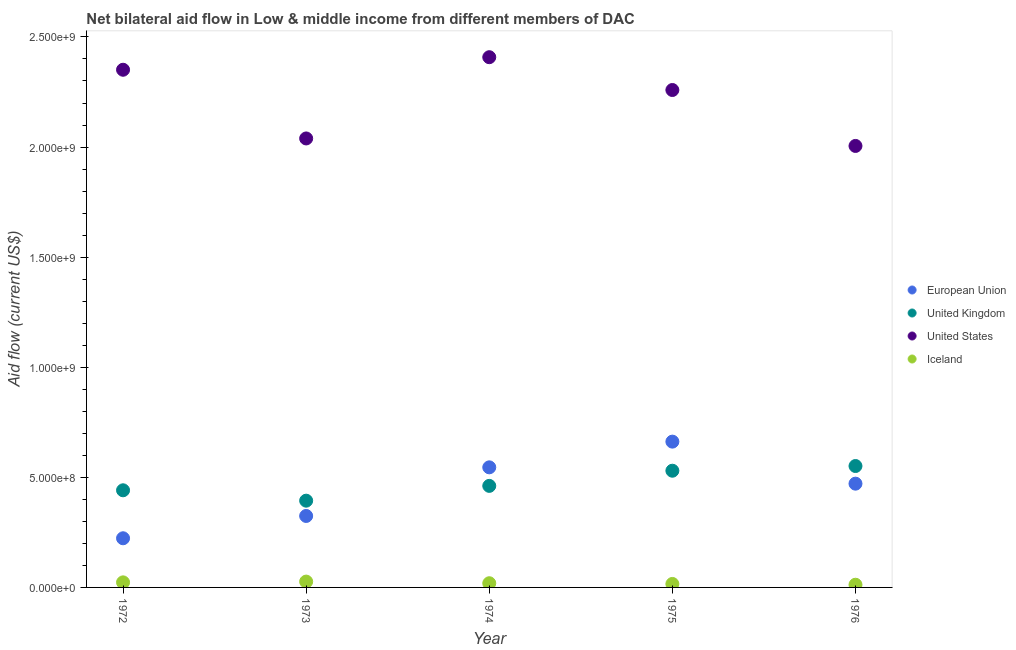What is the amount of aid given by eu in 1974?
Offer a terse response. 5.45e+08. Across all years, what is the maximum amount of aid given by uk?
Ensure brevity in your answer.  5.51e+08. Across all years, what is the minimum amount of aid given by iceland?
Your answer should be very brief. 1.22e+07. In which year was the amount of aid given by us maximum?
Your answer should be very brief. 1974. In which year was the amount of aid given by eu minimum?
Your answer should be very brief. 1972. What is the total amount of aid given by iceland in the graph?
Give a very brief answer. 9.66e+07. What is the difference between the amount of aid given by us in 1973 and that in 1975?
Provide a succinct answer. -2.20e+08. What is the difference between the amount of aid given by us in 1975 and the amount of aid given by uk in 1973?
Offer a terse response. 1.87e+09. What is the average amount of aid given by eu per year?
Keep it short and to the point. 4.45e+08. In the year 1974, what is the difference between the amount of aid given by us and amount of aid given by uk?
Keep it short and to the point. 1.95e+09. In how many years, is the amount of aid given by iceland greater than 1500000000 US$?
Your answer should be very brief. 0. What is the ratio of the amount of aid given by uk in 1972 to that in 1976?
Provide a succinct answer. 0.8. Is the amount of aid given by iceland in 1974 less than that in 1976?
Your response must be concise. No. What is the difference between the highest and the second highest amount of aid given by eu?
Ensure brevity in your answer.  1.17e+08. What is the difference between the highest and the lowest amount of aid given by iceland?
Your answer should be compact. 1.43e+07. In how many years, is the amount of aid given by eu greater than the average amount of aid given by eu taken over all years?
Your answer should be compact. 3. Is it the case that in every year, the sum of the amount of aid given by us and amount of aid given by eu is greater than the sum of amount of aid given by uk and amount of aid given by iceland?
Your answer should be very brief. No. Does the amount of aid given by iceland monotonically increase over the years?
Your answer should be very brief. No. Is the amount of aid given by uk strictly greater than the amount of aid given by eu over the years?
Your response must be concise. No. How many years are there in the graph?
Provide a short and direct response. 5. What is the difference between two consecutive major ticks on the Y-axis?
Provide a succinct answer. 5.00e+08. Where does the legend appear in the graph?
Give a very brief answer. Center right. How are the legend labels stacked?
Offer a terse response. Vertical. What is the title of the graph?
Ensure brevity in your answer.  Net bilateral aid flow in Low & middle income from different members of DAC. What is the label or title of the Y-axis?
Make the answer very short. Aid flow (current US$). What is the Aid flow (current US$) of European Union in 1972?
Keep it short and to the point. 2.23e+08. What is the Aid flow (current US$) of United Kingdom in 1972?
Offer a very short reply. 4.41e+08. What is the Aid flow (current US$) in United States in 1972?
Offer a terse response. 2.35e+09. What is the Aid flow (current US$) of Iceland in 1972?
Your response must be concise. 2.30e+07. What is the Aid flow (current US$) of European Union in 1973?
Your answer should be very brief. 3.25e+08. What is the Aid flow (current US$) of United Kingdom in 1973?
Your answer should be compact. 3.94e+08. What is the Aid flow (current US$) in United States in 1973?
Provide a short and direct response. 2.04e+09. What is the Aid flow (current US$) of Iceland in 1973?
Give a very brief answer. 2.65e+07. What is the Aid flow (current US$) in European Union in 1974?
Offer a terse response. 5.45e+08. What is the Aid flow (current US$) of United Kingdom in 1974?
Your answer should be very brief. 4.61e+08. What is the Aid flow (current US$) in United States in 1974?
Provide a short and direct response. 2.41e+09. What is the Aid flow (current US$) in Iceland in 1974?
Your answer should be very brief. 1.90e+07. What is the Aid flow (current US$) of European Union in 1975?
Keep it short and to the point. 6.62e+08. What is the Aid flow (current US$) of United Kingdom in 1975?
Provide a succinct answer. 5.30e+08. What is the Aid flow (current US$) in United States in 1975?
Make the answer very short. 2.26e+09. What is the Aid flow (current US$) in Iceland in 1975?
Provide a short and direct response. 1.58e+07. What is the Aid flow (current US$) in European Union in 1976?
Make the answer very short. 4.71e+08. What is the Aid flow (current US$) of United Kingdom in 1976?
Your answer should be very brief. 5.51e+08. What is the Aid flow (current US$) in United States in 1976?
Keep it short and to the point. 2.00e+09. What is the Aid flow (current US$) in Iceland in 1976?
Make the answer very short. 1.22e+07. Across all years, what is the maximum Aid flow (current US$) in European Union?
Your response must be concise. 6.62e+08. Across all years, what is the maximum Aid flow (current US$) of United Kingdom?
Ensure brevity in your answer.  5.51e+08. Across all years, what is the maximum Aid flow (current US$) in United States?
Your answer should be very brief. 2.41e+09. Across all years, what is the maximum Aid flow (current US$) in Iceland?
Give a very brief answer. 2.65e+07. Across all years, what is the minimum Aid flow (current US$) in European Union?
Keep it short and to the point. 2.23e+08. Across all years, what is the minimum Aid flow (current US$) in United Kingdom?
Offer a terse response. 3.94e+08. Across all years, what is the minimum Aid flow (current US$) in United States?
Provide a succinct answer. 2.00e+09. Across all years, what is the minimum Aid flow (current US$) in Iceland?
Your response must be concise. 1.22e+07. What is the total Aid flow (current US$) of European Union in the graph?
Offer a very short reply. 2.23e+09. What is the total Aid flow (current US$) of United Kingdom in the graph?
Keep it short and to the point. 2.38e+09. What is the total Aid flow (current US$) of United States in the graph?
Offer a very short reply. 1.11e+1. What is the total Aid flow (current US$) of Iceland in the graph?
Your response must be concise. 9.66e+07. What is the difference between the Aid flow (current US$) of European Union in 1972 and that in 1973?
Offer a terse response. -1.01e+08. What is the difference between the Aid flow (current US$) in United Kingdom in 1972 and that in 1973?
Your answer should be very brief. 4.72e+07. What is the difference between the Aid flow (current US$) in United States in 1972 and that in 1973?
Your answer should be very brief. 3.12e+08. What is the difference between the Aid flow (current US$) of Iceland in 1972 and that in 1973?
Provide a short and direct response. -3.48e+06. What is the difference between the Aid flow (current US$) of European Union in 1972 and that in 1974?
Offer a terse response. -3.22e+08. What is the difference between the Aid flow (current US$) of United Kingdom in 1972 and that in 1974?
Provide a succinct answer. -2.00e+07. What is the difference between the Aid flow (current US$) in United States in 1972 and that in 1974?
Offer a very short reply. -5.70e+07. What is the difference between the Aid flow (current US$) in Iceland in 1972 and that in 1974?
Provide a short and direct response. 3.97e+06. What is the difference between the Aid flow (current US$) in European Union in 1972 and that in 1975?
Provide a succinct answer. -4.39e+08. What is the difference between the Aid flow (current US$) of United Kingdom in 1972 and that in 1975?
Your answer should be very brief. -8.89e+07. What is the difference between the Aid flow (current US$) in United States in 1972 and that in 1975?
Your answer should be very brief. 9.20e+07. What is the difference between the Aid flow (current US$) of Iceland in 1972 and that in 1975?
Offer a very short reply. 7.21e+06. What is the difference between the Aid flow (current US$) in European Union in 1972 and that in 1976?
Provide a succinct answer. -2.48e+08. What is the difference between the Aid flow (current US$) in United Kingdom in 1972 and that in 1976?
Provide a succinct answer. -1.10e+08. What is the difference between the Aid flow (current US$) of United States in 1972 and that in 1976?
Give a very brief answer. 3.46e+08. What is the difference between the Aid flow (current US$) in Iceland in 1972 and that in 1976?
Provide a succinct answer. 1.08e+07. What is the difference between the Aid flow (current US$) of European Union in 1973 and that in 1974?
Give a very brief answer. -2.21e+08. What is the difference between the Aid flow (current US$) in United Kingdom in 1973 and that in 1974?
Give a very brief answer. -6.72e+07. What is the difference between the Aid flow (current US$) of United States in 1973 and that in 1974?
Provide a short and direct response. -3.69e+08. What is the difference between the Aid flow (current US$) of Iceland in 1973 and that in 1974?
Your answer should be compact. 7.45e+06. What is the difference between the Aid flow (current US$) of European Union in 1973 and that in 1975?
Keep it short and to the point. -3.38e+08. What is the difference between the Aid flow (current US$) in United Kingdom in 1973 and that in 1975?
Provide a succinct answer. -1.36e+08. What is the difference between the Aid flow (current US$) in United States in 1973 and that in 1975?
Provide a succinct answer. -2.20e+08. What is the difference between the Aid flow (current US$) of Iceland in 1973 and that in 1975?
Your response must be concise. 1.07e+07. What is the difference between the Aid flow (current US$) of European Union in 1973 and that in 1976?
Your answer should be very brief. -1.47e+08. What is the difference between the Aid flow (current US$) of United Kingdom in 1973 and that in 1976?
Ensure brevity in your answer.  -1.57e+08. What is the difference between the Aid flow (current US$) of United States in 1973 and that in 1976?
Your answer should be very brief. 3.40e+07. What is the difference between the Aid flow (current US$) of Iceland in 1973 and that in 1976?
Provide a short and direct response. 1.43e+07. What is the difference between the Aid flow (current US$) of European Union in 1974 and that in 1975?
Keep it short and to the point. -1.17e+08. What is the difference between the Aid flow (current US$) of United Kingdom in 1974 and that in 1975?
Offer a very short reply. -6.89e+07. What is the difference between the Aid flow (current US$) in United States in 1974 and that in 1975?
Keep it short and to the point. 1.49e+08. What is the difference between the Aid flow (current US$) in Iceland in 1974 and that in 1975?
Give a very brief answer. 3.24e+06. What is the difference between the Aid flow (current US$) of European Union in 1974 and that in 1976?
Offer a very short reply. 7.42e+07. What is the difference between the Aid flow (current US$) of United Kingdom in 1974 and that in 1976?
Make the answer very short. -9.02e+07. What is the difference between the Aid flow (current US$) of United States in 1974 and that in 1976?
Give a very brief answer. 4.03e+08. What is the difference between the Aid flow (current US$) in Iceland in 1974 and that in 1976?
Offer a terse response. 6.82e+06. What is the difference between the Aid flow (current US$) in European Union in 1975 and that in 1976?
Offer a very short reply. 1.91e+08. What is the difference between the Aid flow (current US$) in United Kingdom in 1975 and that in 1976?
Ensure brevity in your answer.  -2.13e+07. What is the difference between the Aid flow (current US$) of United States in 1975 and that in 1976?
Provide a succinct answer. 2.54e+08. What is the difference between the Aid flow (current US$) of Iceland in 1975 and that in 1976?
Offer a terse response. 3.58e+06. What is the difference between the Aid flow (current US$) in European Union in 1972 and the Aid flow (current US$) in United Kingdom in 1973?
Make the answer very short. -1.71e+08. What is the difference between the Aid flow (current US$) in European Union in 1972 and the Aid flow (current US$) in United States in 1973?
Your answer should be compact. -1.82e+09. What is the difference between the Aid flow (current US$) of European Union in 1972 and the Aid flow (current US$) of Iceland in 1973?
Your answer should be compact. 1.97e+08. What is the difference between the Aid flow (current US$) of United Kingdom in 1972 and the Aid flow (current US$) of United States in 1973?
Provide a short and direct response. -1.60e+09. What is the difference between the Aid flow (current US$) in United Kingdom in 1972 and the Aid flow (current US$) in Iceland in 1973?
Provide a short and direct response. 4.15e+08. What is the difference between the Aid flow (current US$) in United States in 1972 and the Aid flow (current US$) in Iceland in 1973?
Make the answer very short. 2.32e+09. What is the difference between the Aid flow (current US$) in European Union in 1972 and the Aid flow (current US$) in United Kingdom in 1974?
Your answer should be very brief. -2.38e+08. What is the difference between the Aid flow (current US$) in European Union in 1972 and the Aid flow (current US$) in United States in 1974?
Your answer should be very brief. -2.18e+09. What is the difference between the Aid flow (current US$) of European Union in 1972 and the Aid flow (current US$) of Iceland in 1974?
Your answer should be compact. 2.04e+08. What is the difference between the Aid flow (current US$) in United Kingdom in 1972 and the Aid flow (current US$) in United States in 1974?
Provide a succinct answer. -1.97e+09. What is the difference between the Aid flow (current US$) in United Kingdom in 1972 and the Aid flow (current US$) in Iceland in 1974?
Your response must be concise. 4.22e+08. What is the difference between the Aid flow (current US$) of United States in 1972 and the Aid flow (current US$) of Iceland in 1974?
Give a very brief answer. 2.33e+09. What is the difference between the Aid flow (current US$) of European Union in 1972 and the Aid flow (current US$) of United Kingdom in 1975?
Ensure brevity in your answer.  -3.07e+08. What is the difference between the Aid flow (current US$) in European Union in 1972 and the Aid flow (current US$) in United States in 1975?
Your answer should be very brief. -2.04e+09. What is the difference between the Aid flow (current US$) of European Union in 1972 and the Aid flow (current US$) of Iceland in 1975?
Provide a short and direct response. 2.07e+08. What is the difference between the Aid flow (current US$) of United Kingdom in 1972 and the Aid flow (current US$) of United States in 1975?
Offer a terse response. -1.82e+09. What is the difference between the Aid flow (current US$) of United Kingdom in 1972 and the Aid flow (current US$) of Iceland in 1975?
Your answer should be compact. 4.25e+08. What is the difference between the Aid flow (current US$) in United States in 1972 and the Aid flow (current US$) in Iceland in 1975?
Ensure brevity in your answer.  2.34e+09. What is the difference between the Aid flow (current US$) of European Union in 1972 and the Aid flow (current US$) of United Kingdom in 1976?
Keep it short and to the point. -3.28e+08. What is the difference between the Aid flow (current US$) in European Union in 1972 and the Aid flow (current US$) in United States in 1976?
Your answer should be compact. -1.78e+09. What is the difference between the Aid flow (current US$) in European Union in 1972 and the Aid flow (current US$) in Iceland in 1976?
Keep it short and to the point. 2.11e+08. What is the difference between the Aid flow (current US$) in United Kingdom in 1972 and the Aid flow (current US$) in United States in 1976?
Give a very brief answer. -1.56e+09. What is the difference between the Aid flow (current US$) of United Kingdom in 1972 and the Aid flow (current US$) of Iceland in 1976?
Make the answer very short. 4.29e+08. What is the difference between the Aid flow (current US$) of United States in 1972 and the Aid flow (current US$) of Iceland in 1976?
Ensure brevity in your answer.  2.34e+09. What is the difference between the Aid flow (current US$) in European Union in 1973 and the Aid flow (current US$) in United Kingdom in 1974?
Provide a short and direct response. -1.37e+08. What is the difference between the Aid flow (current US$) in European Union in 1973 and the Aid flow (current US$) in United States in 1974?
Keep it short and to the point. -2.08e+09. What is the difference between the Aid flow (current US$) of European Union in 1973 and the Aid flow (current US$) of Iceland in 1974?
Keep it short and to the point. 3.06e+08. What is the difference between the Aid flow (current US$) in United Kingdom in 1973 and the Aid flow (current US$) in United States in 1974?
Offer a very short reply. -2.01e+09. What is the difference between the Aid flow (current US$) of United Kingdom in 1973 and the Aid flow (current US$) of Iceland in 1974?
Your answer should be compact. 3.75e+08. What is the difference between the Aid flow (current US$) in United States in 1973 and the Aid flow (current US$) in Iceland in 1974?
Keep it short and to the point. 2.02e+09. What is the difference between the Aid flow (current US$) in European Union in 1973 and the Aid flow (current US$) in United Kingdom in 1975?
Give a very brief answer. -2.05e+08. What is the difference between the Aid flow (current US$) in European Union in 1973 and the Aid flow (current US$) in United States in 1975?
Keep it short and to the point. -1.93e+09. What is the difference between the Aid flow (current US$) of European Union in 1973 and the Aid flow (current US$) of Iceland in 1975?
Your answer should be compact. 3.09e+08. What is the difference between the Aid flow (current US$) in United Kingdom in 1973 and the Aid flow (current US$) in United States in 1975?
Your answer should be compact. -1.87e+09. What is the difference between the Aid flow (current US$) of United Kingdom in 1973 and the Aid flow (current US$) of Iceland in 1975?
Keep it short and to the point. 3.78e+08. What is the difference between the Aid flow (current US$) in United States in 1973 and the Aid flow (current US$) in Iceland in 1975?
Your answer should be compact. 2.02e+09. What is the difference between the Aid flow (current US$) of European Union in 1973 and the Aid flow (current US$) of United Kingdom in 1976?
Your answer should be compact. -2.27e+08. What is the difference between the Aid flow (current US$) of European Union in 1973 and the Aid flow (current US$) of United States in 1976?
Make the answer very short. -1.68e+09. What is the difference between the Aid flow (current US$) of European Union in 1973 and the Aid flow (current US$) of Iceland in 1976?
Provide a short and direct response. 3.12e+08. What is the difference between the Aid flow (current US$) in United Kingdom in 1973 and the Aid flow (current US$) in United States in 1976?
Your answer should be very brief. -1.61e+09. What is the difference between the Aid flow (current US$) in United Kingdom in 1973 and the Aid flow (current US$) in Iceland in 1976?
Your answer should be compact. 3.82e+08. What is the difference between the Aid flow (current US$) in United States in 1973 and the Aid flow (current US$) in Iceland in 1976?
Your response must be concise. 2.03e+09. What is the difference between the Aid flow (current US$) of European Union in 1974 and the Aid flow (current US$) of United Kingdom in 1975?
Your answer should be very brief. 1.54e+07. What is the difference between the Aid flow (current US$) in European Union in 1974 and the Aid flow (current US$) in United States in 1975?
Your answer should be very brief. -1.71e+09. What is the difference between the Aid flow (current US$) in European Union in 1974 and the Aid flow (current US$) in Iceland in 1975?
Make the answer very short. 5.30e+08. What is the difference between the Aid flow (current US$) in United Kingdom in 1974 and the Aid flow (current US$) in United States in 1975?
Your response must be concise. -1.80e+09. What is the difference between the Aid flow (current US$) in United Kingdom in 1974 and the Aid flow (current US$) in Iceland in 1975?
Provide a succinct answer. 4.45e+08. What is the difference between the Aid flow (current US$) in United States in 1974 and the Aid flow (current US$) in Iceland in 1975?
Your response must be concise. 2.39e+09. What is the difference between the Aid flow (current US$) in European Union in 1974 and the Aid flow (current US$) in United Kingdom in 1976?
Offer a terse response. -5.96e+06. What is the difference between the Aid flow (current US$) of European Union in 1974 and the Aid flow (current US$) of United States in 1976?
Give a very brief answer. -1.46e+09. What is the difference between the Aid flow (current US$) of European Union in 1974 and the Aid flow (current US$) of Iceland in 1976?
Ensure brevity in your answer.  5.33e+08. What is the difference between the Aid flow (current US$) of United Kingdom in 1974 and the Aid flow (current US$) of United States in 1976?
Give a very brief answer. -1.54e+09. What is the difference between the Aid flow (current US$) in United Kingdom in 1974 and the Aid flow (current US$) in Iceland in 1976?
Keep it short and to the point. 4.49e+08. What is the difference between the Aid flow (current US$) of United States in 1974 and the Aid flow (current US$) of Iceland in 1976?
Keep it short and to the point. 2.40e+09. What is the difference between the Aid flow (current US$) of European Union in 1975 and the Aid flow (current US$) of United Kingdom in 1976?
Your answer should be very brief. 1.11e+08. What is the difference between the Aid flow (current US$) in European Union in 1975 and the Aid flow (current US$) in United States in 1976?
Offer a terse response. -1.34e+09. What is the difference between the Aid flow (current US$) in European Union in 1975 and the Aid flow (current US$) in Iceland in 1976?
Your response must be concise. 6.50e+08. What is the difference between the Aid flow (current US$) of United Kingdom in 1975 and the Aid flow (current US$) of United States in 1976?
Make the answer very short. -1.47e+09. What is the difference between the Aid flow (current US$) in United Kingdom in 1975 and the Aid flow (current US$) in Iceland in 1976?
Make the answer very short. 5.18e+08. What is the difference between the Aid flow (current US$) in United States in 1975 and the Aid flow (current US$) in Iceland in 1976?
Your answer should be compact. 2.25e+09. What is the average Aid flow (current US$) of European Union per year?
Ensure brevity in your answer.  4.45e+08. What is the average Aid flow (current US$) in United Kingdom per year?
Provide a succinct answer. 4.76e+08. What is the average Aid flow (current US$) in United States per year?
Give a very brief answer. 2.21e+09. What is the average Aid flow (current US$) of Iceland per year?
Provide a short and direct response. 1.93e+07. In the year 1972, what is the difference between the Aid flow (current US$) in European Union and Aid flow (current US$) in United Kingdom?
Provide a succinct answer. -2.18e+08. In the year 1972, what is the difference between the Aid flow (current US$) of European Union and Aid flow (current US$) of United States?
Offer a very short reply. -2.13e+09. In the year 1972, what is the difference between the Aid flow (current US$) in European Union and Aid flow (current US$) in Iceland?
Your answer should be very brief. 2.00e+08. In the year 1972, what is the difference between the Aid flow (current US$) in United Kingdom and Aid flow (current US$) in United States?
Provide a succinct answer. -1.91e+09. In the year 1972, what is the difference between the Aid flow (current US$) in United Kingdom and Aid flow (current US$) in Iceland?
Provide a short and direct response. 4.18e+08. In the year 1972, what is the difference between the Aid flow (current US$) in United States and Aid flow (current US$) in Iceland?
Ensure brevity in your answer.  2.33e+09. In the year 1973, what is the difference between the Aid flow (current US$) of European Union and Aid flow (current US$) of United Kingdom?
Ensure brevity in your answer.  -6.94e+07. In the year 1973, what is the difference between the Aid flow (current US$) of European Union and Aid flow (current US$) of United States?
Your answer should be very brief. -1.71e+09. In the year 1973, what is the difference between the Aid flow (current US$) of European Union and Aid flow (current US$) of Iceland?
Ensure brevity in your answer.  2.98e+08. In the year 1973, what is the difference between the Aid flow (current US$) of United Kingdom and Aid flow (current US$) of United States?
Ensure brevity in your answer.  -1.65e+09. In the year 1973, what is the difference between the Aid flow (current US$) in United Kingdom and Aid flow (current US$) in Iceland?
Ensure brevity in your answer.  3.68e+08. In the year 1973, what is the difference between the Aid flow (current US$) of United States and Aid flow (current US$) of Iceland?
Your answer should be very brief. 2.01e+09. In the year 1974, what is the difference between the Aid flow (current US$) of European Union and Aid flow (current US$) of United Kingdom?
Offer a very short reply. 8.42e+07. In the year 1974, what is the difference between the Aid flow (current US$) in European Union and Aid flow (current US$) in United States?
Offer a terse response. -1.86e+09. In the year 1974, what is the difference between the Aid flow (current US$) of European Union and Aid flow (current US$) of Iceland?
Ensure brevity in your answer.  5.26e+08. In the year 1974, what is the difference between the Aid flow (current US$) in United Kingdom and Aid flow (current US$) in United States?
Make the answer very short. -1.95e+09. In the year 1974, what is the difference between the Aid flow (current US$) in United Kingdom and Aid flow (current US$) in Iceland?
Your answer should be very brief. 4.42e+08. In the year 1974, what is the difference between the Aid flow (current US$) in United States and Aid flow (current US$) in Iceland?
Ensure brevity in your answer.  2.39e+09. In the year 1975, what is the difference between the Aid flow (current US$) in European Union and Aid flow (current US$) in United Kingdom?
Ensure brevity in your answer.  1.32e+08. In the year 1975, what is the difference between the Aid flow (current US$) of European Union and Aid flow (current US$) of United States?
Keep it short and to the point. -1.60e+09. In the year 1975, what is the difference between the Aid flow (current US$) in European Union and Aid flow (current US$) in Iceland?
Your answer should be very brief. 6.46e+08. In the year 1975, what is the difference between the Aid flow (current US$) of United Kingdom and Aid flow (current US$) of United States?
Your response must be concise. -1.73e+09. In the year 1975, what is the difference between the Aid flow (current US$) in United Kingdom and Aid flow (current US$) in Iceland?
Offer a very short reply. 5.14e+08. In the year 1975, what is the difference between the Aid flow (current US$) in United States and Aid flow (current US$) in Iceland?
Offer a terse response. 2.24e+09. In the year 1976, what is the difference between the Aid flow (current US$) in European Union and Aid flow (current US$) in United Kingdom?
Keep it short and to the point. -8.01e+07. In the year 1976, what is the difference between the Aid flow (current US$) of European Union and Aid flow (current US$) of United States?
Keep it short and to the point. -1.53e+09. In the year 1976, what is the difference between the Aid flow (current US$) of European Union and Aid flow (current US$) of Iceland?
Your answer should be very brief. 4.59e+08. In the year 1976, what is the difference between the Aid flow (current US$) of United Kingdom and Aid flow (current US$) of United States?
Ensure brevity in your answer.  -1.45e+09. In the year 1976, what is the difference between the Aid flow (current US$) in United Kingdom and Aid flow (current US$) in Iceland?
Provide a short and direct response. 5.39e+08. In the year 1976, what is the difference between the Aid flow (current US$) in United States and Aid flow (current US$) in Iceland?
Provide a short and direct response. 1.99e+09. What is the ratio of the Aid flow (current US$) of European Union in 1972 to that in 1973?
Your answer should be compact. 0.69. What is the ratio of the Aid flow (current US$) in United Kingdom in 1972 to that in 1973?
Your answer should be very brief. 1.12. What is the ratio of the Aid flow (current US$) in United States in 1972 to that in 1973?
Your answer should be compact. 1.15. What is the ratio of the Aid flow (current US$) in Iceland in 1972 to that in 1973?
Provide a succinct answer. 0.87. What is the ratio of the Aid flow (current US$) in European Union in 1972 to that in 1974?
Provide a succinct answer. 0.41. What is the ratio of the Aid flow (current US$) of United Kingdom in 1972 to that in 1974?
Offer a terse response. 0.96. What is the ratio of the Aid flow (current US$) of United States in 1972 to that in 1974?
Ensure brevity in your answer.  0.98. What is the ratio of the Aid flow (current US$) in Iceland in 1972 to that in 1974?
Ensure brevity in your answer.  1.21. What is the ratio of the Aid flow (current US$) in European Union in 1972 to that in 1975?
Ensure brevity in your answer.  0.34. What is the ratio of the Aid flow (current US$) of United Kingdom in 1972 to that in 1975?
Make the answer very short. 0.83. What is the ratio of the Aid flow (current US$) of United States in 1972 to that in 1975?
Give a very brief answer. 1.04. What is the ratio of the Aid flow (current US$) of Iceland in 1972 to that in 1975?
Provide a succinct answer. 1.46. What is the ratio of the Aid flow (current US$) of European Union in 1972 to that in 1976?
Keep it short and to the point. 0.47. What is the ratio of the Aid flow (current US$) in United Kingdom in 1972 to that in 1976?
Your answer should be very brief. 0.8. What is the ratio of the Aid flow (current US$) of United States in 1972 to that in 1976?
Make the answer very short. 1.17. What is the ratio of the Aid flow (current US$) of Iceland in 1972 to that in 1976?
Keep it short and to the point. 1.88. What is the ratio of the Aid flow (current US$) of European Union in 1973 to that in 1974?
Offer a terse response. 0.6. What is the ratio of the Aid flow (current US$) of United Kingdom in 1973 to that in 1974?
Give a very brief answer. 0.85. What is the ratio of the Aid flow (current US$) in United States in 1973 to that in 1974?
Offer a terse response. 0.85. What is the ratio of the Aid flow (current US$) of Iceland in 1973 to that in 1974?
Provide a short and direct response. 1.39. What is the ratio of the Aid flow (current US$) of European Union in 1973 to that in 1975?
Offer a very short reply. 0.49. What is the ratio of the Aid flow (current US$) in United Kingdom in 1973 to that in 1975?
Your answer should be very brief. 0.74. What is the ratio of the Aid flow (current US$) in United States in 1973 to that in 1975?
Your answer should be very brief. 0.9. What is the ratio of the Aid flow (current US$) of Iceland in 1973 to that in 1975?
Your response must be concise. 1.68. What is the ratio of the Aid flow (current US$) of European Union in 1973 to that in 1976?
Make the answer very short. 0.69. What is the ratio of the Aid flow (current US$) in United Kingdom in 1973 to that in 1976?
Your answer should be compact. 0.71. What is the ratio of the Aid flow (current US$) in Iceland in 1973 to that in 1976?
Offer a very short reply. 2.17. What is the ratio of the Aid flow (current US$) of European Union in 1974 to that in 1975?
Your answer should be compact. 0.82. What is the ratio of the Aid flow (current US$) in United Kingdom in 1974 to that in 1975?
Offer a very short reply. 0.87. What is the ratio of the Aid flow (current US$) of United States in 1974 to that in 1975?
Offer a terse response. 1.07. What is the ratio of the Aid flow (current US$) of Iceland in 1974 to that in 1975?
Your response must be concise. 1.21. What is the ratio of the Aid flow (current US$) in European Union in 1974 to that in 1976?
Give a very brief answer. 1.16. What is the ratio of the Aid flow (current US$) in United Kingdom in 1974 to that in 1976?
Your response must be concise. 0.84. What is the ratio of the Aid flow (current US$) in United States in 1974 to that in 1976?
Ensure brevity in your answer.  1.2. What is the ratio of the Aid flow (current US$) of Iceland in 1974 to that in 1976?
Provide a short and direct response. 1.56. What is the ratio of the Aid flow (current US$) of European Union in 1975 to that in 1976?
Offer a terse response. 1.41. What is the ratio of the Aid flow (current US$) in United Kingdom in 1975 to that in 1976?
Give a very brief answer. 0.96. What is the ratio of the Aid flow (current US$) of United States in 1975 to that in 1976?
Ensure brevity in your answer.  1.13. What is the ratio of the Aid flow (current US$) of Iceland in 1975 to that in 1976?
Ensure brevity in your answer.  1.29. What is the difference between the highest and the second highest Aid flow (current US$) in European Union?
Your response must be concise. 1.17e+08. What is the difference between the highest and the second highest Aid flow (current US$) of United Kingdom?
Ensure brevity in your answer.  2.13e+07. What is the difference between the highest and the second highest Aid flow (current US$) of United States?
Your answer should be compact. 5.70e+07. What is the difference between the highest and the second highest Aid flow (current US$) in Iceland?
Ensure brevity in your answer.  3.48e+06. What is the difference between the highest and the lowest Aid flow (current US$) of European Union?
Make the answer very short. 4.39e+08. What is the difference between the highest and the lowest Aid flow (current US$) in United Kingdom?
Your answer should be compact. 1.57e+08. What is the difference between the highest and the lowest Aid flow (current US$) in United States?
Offer a very short reply. 4.03e+08. What is the difference between the highest and the lowest Aid flow (current US$) of Iceland?
Ensure brevity in your answer.  1.43e+07. 